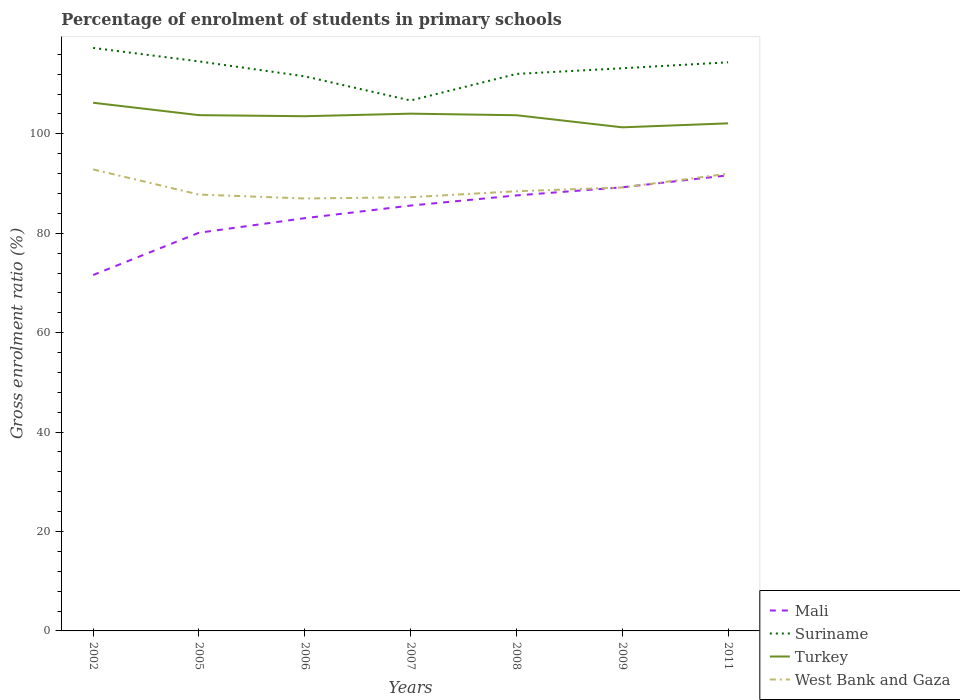How many different coloured lines are there?
Your answer should be very brief. 4. Does the line corresponding to Mali intersect with the line corresponding to Turkey?
Your answer should be very brief. No. Across all years, what is the maximum percentage of students enrolled in primary schools in Mali?
Keep it short and to the point. 71.61. What is the total percentage of students enrolled in primary schools in Turkey in the graph?
Provide a succinct answer. 1.44. What is the difference between the highest and the second highest percentage of students enrolled in primary schools in Turkey?
Provide a short and direct response. 4.95. What is the difference between the highest and the lowest percentage of students enrolled in primary schools in Suriname?
Provide a short and direct response. 4. Is the percentage of students enrolled in primary schools in West Bank and Gaza strictly greater than the percentage of students enrolled in primary schools in Suriname over the years?
Ensure brevity in your answer.  Yes. Are the values on the major ticks of Y-axis written in scientific E-notation?
Ensure brevity in your answer.  No. Does the graph contain any zero values?
Ensure brevity in your answer.  No. Where does the legend appear in the graph?
Your response must be concise. Bottom right. How many legend labels are there?
Ensure brevity in your answer.  4. What is the title of the graph?
Give a very brief answer. Percentage of enrolment of students in primary schools. What is the Gross enrolment ratio (%) in Mali in 2002?
Ensure brevity in your answer.  71.61. What is the Gross enrolment ratio (%) of Suriname in 2002?
Make the answer very short. 117.29. What is the Gross enrolment ratio (%) of Turkey in 2002?
Your response must be concise. 106.26. What is the Gross enrolment ratio (%) in West Bank and Gaza in 2002?
Offer a very short reply. 92.85. What is the Gross enrolment ratio (%) of Mali in 2005?
Ensure brevity in your answer.  80.11. What is the Gross enrolment ratio (%) of Suriname in 2005?
Offer a very short reply. 114.58. What is the Gross enrolment ratio (%) of Turkey in 2005?
Offer a very short reply. 103.77. What is the Gross enrolment ratio (%) of West Bank and Gaza in 2005?
Provide a short and direct response. 87.79. What is the Gross enrolment ratio (%) of Mali in 2006?
Give a very brief answer. 83.04. What is the Gross enrolment ratio (%) of Suriname in 2006?
Provide a short and direct response. 111.58. What is the Gross enrolment ratio (%) of Turkey in 2006?
Your answer should be compact. 103.55. What is the Gross enrolment ratio (%) in West Bank and Gaza in 2006?
Your answer should be compact. 87.01. What is the Gross enrolment ratio (%) of Mali in 2007?
Provide a succinct answer. 85.58. What is the Gross enrolment ratio (%) in Suriname in 2007?
Make the answer very short. 106.72. What is the Gross enrolment ratio (%) in Turkey in 2007?
Your response must be concise. 104.07. What is the Gross enrolment ratio (%) in West Bank and Gaza in 2007?
Your response must be concise. 87.26. What is the Gross enrolment ratio (%) in Mali in 2008?
Provide a succinct answer. 87.62. What is the Gross enrolment ratio (%) in Suriname in 2008?
Ensure brevity in your answer.  112.06. What is the Gross enrolment ratio (%) in Turkey in 2008?
Give a very brief answer. 103.75. What is the Gross enrolment ratio (%) of West Bank and Gaza in 2008?
Your response must be concise. 88.46. What is the Gross enrolment ratio (%) of Mali in 2009?
Offer a terse response. 89.25. What is the Gross enrolment ratio (%) of Suriname in 2009?
Keep it short and to the point. 113.2. What is the Gross enrolment ratio (%) of Turkey in 2009?
Your answer should be compact. 101.32. What is the Gross enrolment ratio (%) of West Bank and Gaza in 2009?
Give a very brief answer. 89.21. What is the Gross enrolment ratio (%) of Mali in 2011?
Ensure brevity in your answer.  91.66. What is the Gross enrolment ratio (%) in Suriname in 2011?
Your response must be concise. 114.4. What is the Gross enrolment ratio (%) of Turkey in 2011?
Ensure brevity in your answer.  102.12. What is the Gross enrolment ratio (%) of West Bank and Gaza in 2011?
Your answer should be very brief. 91.98. Across all years, what is the maximum Gross enrolment ratio (%) of Mali?
Your answer should be very brief. 91.66. Across all years, what is the maximum Gross enrolment ratio (%) of Suriname?
Provide a short and direct response. 117.29. Across all years, what is the maximum Gross enrolment ratio (%) of Turkey?
Your answer should be very brief. 106.26. Across all years, what is the maximum Gross enrolment ratio (%) in West Bank and Gaza?
Offer a terse response. 92.85. Across all years, what is the minimum Gross enrolment ratio (%) in Mali?
Provide a succinct answer. 71.61. Across all years, what is the minimum Gross enrolment ratio (%) of Suriname?
Offer a terse response. 106.72. Across all years, what is the minimum Gross enrolment ratio (%) in Turkey?
Provide a short and direct response. 101.32. Across all years, what is the minimum Gross enrolment ratio (%) in West Bank and Gaza?
Your response must be concise. 87.01. What is the total Gross enrolment ratio (%) of Mali in the graph?
Ensure brevity in your answer.  588.87. What is the total Gross enrolment ratio (%) of Suriname in the graph?
Provide a short and direct response. 789.83. What is the total Gross enrolment ratio (%) of Turkey in the graph?
Your response must be concise. 724.84. What is the total Gross enrolment ratio (%) of West Bank and Gaza in the graph?
Your answer should be very brief. 624.56. What is the difference between the Gross enrolment ratio (%) in Mali in 2002 and that in 2005?
Ensure brevity in your answer.  -8.5. What is the difference between the Gross enrolment ratio (%) of Suriname in 2002 and that in 2005?
Your answer should be very brief. 2.71. What is the difference between the Gross enrolment ratio (%) in Turkey in 2002 and that in 2005?
Provide a succinct answer. 2.5. What is the difference between the Gross enrolment ratio (%) of West Bank and Gaza in 2002 and that in 2005?
Offer a terse response. 5.06. What is the difference between the Gross enrolment ratio (%) of Mali in 2002 and that in 2006?
Make the answer very short. -11.44. What is the difference between the Gross enrolment ratio (%) of Suriname in 2002 and that in 2006?
Your answer should be compact. 5.71. What is the difference between the Gross enrolment ratio (%) in Turkey in 2002 and that in 2006?
Your answer should be very brief. 2.71. What is the difference between the Gross enrolment ratio (%) in West Bank and Gaza in 2002 and that in 2006?
Offer a very short reply. 5.84. What is the difference between the Gross enrolment ratio (%) of Mali in 2002 and that in 2007?
Your answer should be compact. -13.97. What is the difference between the Gross enrolment ratio (%) in Suriname in 2002 and that in 2007?
Offer a terse response. 10.58. What is the difference between the Gross enrolment ratio (%) in Turkey in 2002 and that in 2007?
Give a very brief answer. 2.2. What is the difference between the Gross enrolment ratio (%) of West Bank and Gaza in 2002 and that in 2007?
Offer a very short reply. 5.59. What is the difference between the Gross enrolment ratio (%) of Mali in 2002 and that in 2008?
Ensure brevity in your answer.  -16.01. What is the difference between the Gross enrolment ratio (%) of Suriname in 2002 and that in 2008?
Offer a terse response. 5.23. What is the difference between the Gross enrolment ratio (%) in Turkey in 2002 and that in 2008?
Ensure brevity in your answer.  2.51. What is the difference between the Gross enrolment ratio (%) in West Bank and Gaza in 2002 and that in 2008?
Give a very brief answer. 4.39. What is the difference between the Gross enrolment ratio (%) in Mali in 2002 and that in 2009?
Provide a succinct answer. -17.64. What is the difference between the Gross enrolment ratio (%) of Suriname in 2002 and that in 2009?
Your answer should be very brief. 4.09. What is the difference between the Gross enrolment ratio (%) of Turkey in 2002 and that in 2009?
Your response must be concise. 4.95. What is the difference between the Gross enrolment ratio (%) of West Bank and Gaza in 2002 and that in 2009?
Ensure brevity in your answer.  3.64. What is the difference between the Gross enrolment ratio (%) in Mali in 2002 and that in 2011?
Your response must be concise. -20.06. What is the difference between the Gross enrolment ratio (%) of Suriname in 2002 and that in 2011?
Your answer should be compact. 2.89. What is the difference between the Gross enrolment ratio (%) of Turkey in 2002 and that in 2011?
Give a very brief answer. 4.15. What is the difference between the Gross enrolment ratio (%) of West Bank and Gaza in 2002 and that in 2011?
Offer a terse response. 0.87. What is the difference between the Gross enrolment ratio (%) of Mali in 2005 and that in 2006?
Make the answer very short. -2.93. What is the difference between the Gross enrolment ratio (%) in Suriname in 2005 and that in 2006?
Make the answer very short. 3. What is the difference between the Gross enrolment ratio (%) of Turkey in 2005 and that in 2006?
Provide a short and direct response. 0.21. What is the difference between the Gross enrolment ratio (%) in West Bank and Gaza in 2005 and that in 2006?
Your answer should be very brief. 0.78. What is the difference between the Gross enrolment ratio (%) in Mali in 2005 and that in 2007?
Provide a short and direct response. -5.47. What is the difference between the Gross enrolment ratio (%) in Suriname in 2005 and that in 2007?
Provide a short and direct response. 7.87. What is the difference between the Gross enrolment ratio (%) in Turkey in 2005 and that in 2007?
Ensure brevity in your answer.  -0.3. What is the difference between the Gross enrolment ratio (%) in West Bank and Gaza in 2005 and that in 2007?
Provide a succinct answer. 0.53. What is the difference between the Gross enrolment ratio (%) in Mali in 2005 and that in 2008?
Provide a short and direct response. -7.51. What is the difference between the Gross enrolment ratio (%) of Suriname in 2005 and that in 2008?
Give a very brief answer. 2.52. What is the difference between the Gross enrolment ratio (%) of Turkey in 2005 and that in 2008?
Ensure brevity in your answer.  0.02. What is the difference between the Gross enrolment ratio (%) in West Bank and Gaza in 2005 and that in 2008?
Your answer should be compact. -0.67. What is the difference between the Gross enrolment ratio (%) in Mali in 2005 and that in 2009?
Provide a short and direct response. -9.14. What is the difference between the Gross enrolment ratio (%) in Suriname in 2005 and that in 2009?
Offer a very short reply. 1.39. What is the difference between the Gross enrolment ratio (%) of Turkey in 2005 and that in 2009?
Keep it short and to the point. 2.45. What is the difference between the Gross enrolment ratio (%) in West Bank and Gaza in 2005 and that in 2009?
Ensure brevity in your answer.  -1.42. What is the difference between the Gross enrolment ratio (%) of Mali in 2005 and that in 2011?
Your answer should be very brief. -11.55. What is the difference between the Gross enrolment ratio (%) of Suriname in 2005 and that in 2011?
Ensure brevity in your answer.  0.18. What is the difference between the Gross enrolment ratio (%) in Turkey in 2005 and that in 2011?
Offer a terse response. 1.65. What is the difference between the Gross enrolment ratio (%) of West Bank and Gaza in 2005 and that in 2011?
Your answer should be compact. -4.19. What is the difference between the Gross enrolment ratio (%) of Mali in 2006 and that in 2007?
Provide a succinct answer. -2.53. What is the difference between the Gross enrolment ratio (%) of Suriname in 2006 and that in 2007?
Ensure brevity in your answer.  4.86. What is the difference between the Gross enrolment ratio (%) of Turkey in 2006 and that in 2007?
Offer a terse response. -0.51. What is the difference between the Gross enrolment ratio (%) in West Bank and Gaza in 2006 and that in 2007?
Keep it short and to the point. -0.25. What is the difference between the Gross enrolment ratio (%) in Mali in 2006 and that in 2008?
Make the answer very short. -4.58. What is the difference between the Gross enrolment ratio (%) of Suriname in 2006 and that in 2008?
Keep it short and to the point. -0.48. What is the difference between the Gross enrolment ratio (%) in Turkey in 2006 and that in 2008?
Provide a succinct answer. -0.2. What is the difference between the Gross enrolment ratio (%) of West Bank and Gaza in 2006 and that in 2008?
Provide a short and direct response. -1.46. What is the difference between the Gross enrolment ratio (%) in Mali in 2006 and that in 2009?
Provide a short and direct response. -6.21. What is the difference between the Gross enrolment ratio (%) in Suriname in 2006 and that in 2009?
Ensure brevity in your answer.  -1.62. What is the difference between the Gross enrolment ratio (%) in Turkey in 2006 and that in 2009?
Make the answer very short. 2.24. What is the difference between the Gross enrolment ratio (%) of West Bank and Gaza in 2006 and that in 2009?
Your answer should be compact. -2.21. What is the difference between the Gross enrolment ratio (%) in Mali in 2006 and that in 2011?
Your answer should be very brief. -8.62. What is the difference between the Gross enrolment ratio (%) of Suriname in 2006 and that in 2011?
Keep it short and to the point. -2.82. What is the difference between the Gross enrolment ratio (%) of Turkey in 2006 and that in 2011?
Offer a very short reply. 1.44. What is the difference between the Gross enrolment ratio (%) of West Bank and Gaza in 2006 and that in 2011?
Keep it short and to the point. -4.97. What is the difference between the Gross enrolment ratio (%) in Mali in 2007 and that in 2008?
Provide a short and direct response. -2.04. What is the difference between the Gross enrolment ratio (%) of Suriname in 2007 and that in 2008?
Provide a succinct answer. -5.34. What is the difference between the Gross enrolment ratio (%) of Turkey in 2007 and that in 2008?
Provide a short and direct response. 0.32. What is the difference between the Gross enrolment ratio (%) of West Bank and Gaza in 2007 and that in 2008?
Keep it short and to the point. -1.21. What is the difference between the Gross enrolment ratio (%) in Mali in 2007 and that in 2009?
Make the answer very short. -3.67. What is the difference between the Gross enrolment ratio (%) in Suriname in 2007 and that in 2009?
Ensure brevity in your answer.  -6.48. What is the difference between the Gross enrolment ratio (%) of Turkey in 2007 and that in 2009?
Your answer should be compact. 2.75. What is the difference between the Gross enrolment ratio (%) in West Bank and Gaza in 2007 and that in 2009?
Offer a terse response. -1.96. What is the difference between the Gross enrolment ratio (%) in Mali in 2007 and that in 2011?
Your answer should be very brief. -6.09. What is the difference between the Gross enrolment ratio (%) of Suriname in 2007 and that in 2011?
Provide a succinct answer. -7.69. What is the difference between the Gross enrolment ratio (%) in Turkey in 2007 and that in 2011?
Offer a very short reply. 1.95. What is the difference between the Gross enrolment ratio (%) of West Bank and Gaza in 2007 and that in 2011?
Give a very brief answer. -4.72. What is the difference between the Gross enrolment ratio (%) of Mali in 2008 and that in 2009?
Ensure brevity in your answer.  -1.63. What is the difference between the Gross enrolment ratio (%) of Suriname in 2008 and that in 2009?
Your response must be concise. -1.14. What is the difference between the Gross enrolment ratio (%) of Turkey in 2008 and that in 2009?
Ensure brevity in your answer.  2.43. What is the difference between the Gross enrolment ratio (%) of West Bank and Gaza in 2008 and that in 2009?
Your answer should be very brief. -0.75. What is the difference between the Gross enrolment ratio (%) of Mali in 2008 and that in 2011?
Give a very brief answer. -4.04. What is the difference between the Gross enrolment ratio (%) in Suriname in 2008 and that in 2011?
Provide a succinct answer. -2.34. What is the difference between the Gross enrolment ratio (%) in Turkey in 2008 and that in 2011?
Your response must be concise. 1.64. What is the difference between the Gross enrolment ratio (%) of West Bank and Gaza in 2008 and that in 2011?
Keep it short and to the point. -3.52. What is the difference between the Gross enrolment ratio (%) of Mali in 2009 and that in 2011?
Your answer should be compact. -2.41. What is the difference between the Gross enrolment ratio (%) of Suriname in 2009 and that in 2011?
Make the answer very short. -1.2. What is the difference between the Gross enrolment ratio (%) of Turkey in 2009 and that in 2011?
Make the answer very short. -0.8. What is the difference between the Gross enrolment ratio (%) in West Bank and Gaza in 2009 and that in 2011?
Give a very brief answer. -2.77. What is the difference between the Gross enrolment ratio (%) of Mali in 2002 and the Gross enrolment ratio (%) of Suriname in 2005?
Your answer should be compact. -42.98. What is the difference between the Gross enrolment ratio (%) of Mali in 2002 and the Gross enrolment ratio (%) of Turkey in 2005?
Offer a very short reply. -32.16. What is the difference between the Gross enrolment ratio (%) in Mali in 2002 and the Gross enrolment ratio (%) in West Bank and Gaza in 2005?
Keep it short and to the point. -16.18. What is the difference between the Gross enrolment ratio (%) in Suriname in 2002 and the Gross enrolment ratio (%) in Turkey in 2005?
Provide a succinct answer. 13.52. What is the difference between the Gross enrolment ratio (%) of Suriname in 2002 and the Gross enrolment ratio (%) of West Bank and Gaza in 2005?
Give a very brief answer. 29.5. What is the difference between the Gross enrolment ratio (%) in Turkey in 2002 and the Gross enrolment ratio (%) in West Bank and Gaza in 2005?
Your response must be concise. 18.47. What is the difference between the Gross enrolment ratio (%) in Mali in 2002 and the Gross enrolment ratio (%) in Suriname in 2006?
Offer a very short reply. -39.97. What is the difference between the Gross enrolment ratio (%) in Mali in 2002 and the Gross enrolment ratio (%) in Turkey in 2006?
Ensure brevity in your answer.  -31.95. What is the difference between the Gross enrolment ratio (%) in Mali in 2002 and the Gross enrolment ratio (%) in West Bank and Gaza in 2006?
Ensure brevity in your answer.  -15.4. What is the difference between the Gross enrolment ratio (%) of Suriname in 2002 and the Gross enrolment ratio (%) of Turkey in 2006?
Offer a terse response. 13.74. What is the difference between the Gross enrolment ratio (%) in Suriname in 2002 and the Gross enrolment ratio (%) in West Bank and Gaza in 2006?
Your response must be concise. 30.29. What is the difference between the Gross enrolment ratio (%) in Turkey in 2002 and the Gross enrolment ratio (%) in West Bank and Gaza in 2006?
Provide a short and direct response. 19.26. What is the difference between the Gross enrolment ratio (%) of Mali in 2002 and the Gross enrolment ratio (%) of Suriname in 2007?
Keep it short and to the point. -35.11. What is the difference between the Gross enrolment ratio (%) of Mali in 2002 and the Gross enrolment ratio (%) of Turkey in 2007?
Offer a terse response. -32.46. What is the difference between the Gross enrolment ratio (%) in Mali in 2002 and the Gross enrolment ratio (%) in West Bank and Gaza in 2007?
Offer a very short reply. -15.65. What is the difference between the Gross enrolment ratio (%) of Suriname in 2002 and the Gross enrolment ratio (%) of Turkey in 2007?
Offer a very short reply. 13.22. What is the difference between the Gross enrolment ratio (%) in Suriname in 2002 and the Gross enrolment ratio (%) in West Bank and Gaza in 2007?
Your response must be concise. 30.04. What is the difference between the Gross enrolment ratio (%) in Turkey in 2002 and the Gross enrolment ratio (%) in West Bank and Gaza in 2007?
Offer a terse response. 19.01. What is the difference between the Gross enrolment ratio (%) in Mali in 2002 and the Gross enrolment ratio (%) in Suriname in 2008?
Give a very brief answer. -40.45. What is the difference between the Gross enrolment ratio (%) in Mali in 2002 and the Gross enrolment ratio (%) in Turkey in 2008?
Provide a succinct answer. -32.14. What is the difference between the Gross enrolment ratio (%) of Mali in 2002 and the Gross enrolment ratio (%) of West Bank and Gaza in 2008?
Offer a terse response. -16.85. What is the difference between the Gross enrolment ratio (%) of Suriname in 2002 and the Gross enrolment ratio (%) of Turkey in 2008?
Provide a short and direct response. 13.54. What is the difference between the Gross enrolment ratio (%) in Suriname in 2002 and the Gross enrolment ratio (%) in West Bank and Gaza in 2008?
Offer a terse response. 28.83. What is the difference between the Gross enrolment ratio (%) of Turkey in 2002 and the Gross enrolment ratio (%) of West Bank and Gaza in 2008?
Your answer should be very brief. 17.8. What is the difference between the Gross enrolment ratio (%) in Mali in 2002 and the Gross enrolment ratio (%) in Suriname in 2009?
Offer a very short reply. -41.59. What is the difference between the Gross enrolment ratio (%) in Mali in 2002 and the Gross enrolment ratio (%) in Turkey in 2009?
Your answer should be compact. -29.71. What is the difference between the Gross enrolment ratio (%) of Mali in 2002 and the Gross enrolment ratio (%) of West Bank and Gaza in 2009?
Your answer should be compact. -17.61. What is the difference between the Gross enrolment ratio (%) of Suriname in 2002 and the Gross enrolment ratio (%) of Turkey in 2009?
Make the answer very short. 15.97. What is the difference between the Gross enrolment ratio (%) of Suriname in 2002 and the Gross enrolment ratio (%) of West Bank and Gaza in 2009?
Your answer should be compact. 28.08. What is the difference between the Gross enrolment ratio (%) of Turkey in 2002 and the Gross enrolment ratio (%) of West Bank and Gaza in 2009?
Your answer should be compact. 17.05. What is the difference between the Gross enrolment ratio (%) in Mali in 2002 and the Gross enrolment ratio (%) in Suriname in 2011?
Offer a very short reply. -42.79. What is the difference between the Gross enrolment ratio (%) in Mali in 2002 and the Gross enrolment ratio (%) in Turkey in 2011?
Offer a terse response. -30.51. What is the difference between the Gross enrolment ratio (%) of Mali in 2002 and the Gross enrolment ratio (%) of West Bank and Gaza in 2011?
Your answer should be compact. -20.37. What is the difference between the Gross enrolment ratio (%) in Suriname in 2002 and the Gross enrolment ratio (%) in Turkey in 2011?
Offer a terse response. 15.18. What is the difference between the Gross enrolment ratio (%) of Suriname in 2002 and the Gross enrolment ratio (%) of West Bank and Gaza in 2011?
Ensure brevity in your answer.  25.31. What is the difference between the Gross enrolment ratio (%) in Turkey in 2002 and the Gross enrolment ratio (%) in West Bank and Gaza in 2011?
Your response must be concise. 14.29. What is the difference between the Gross enrolment ratio (%) of Mali in 2005 and the Gross enrolment ratio (%) of Suriname in 2006?
Your answer should be compact. -31.47. What is the difference between the Gross enrolment ratio (%) of Mali in 2005 and the Gross enrolment ratio (%) of Turkey in 2006?
Your answer should be very brief. -23.44. What is the difference between the Gross enrolment ratio (%) in Mali in 2005 and the Gross enrolment ratio (%) in West Bank and Gaza in 2006?
Your answer should be very brief. -6.89. What is the difference between the Gross enrolment ratio (%) in Suriname in 2005 and the Gross enrolment ratio (%) in Turkey in 2006?
Keep it short and to the point. 11.03. What is the difference between the Gross enrolment ratio (%) of Suriname in 2005 and the Gross enrolment ratio (%) of West Bank and Gaza in 2006?
Give a very brief answer. 27.58. What is the difference between the Gross enrolment ratio (%) of Turkey in 2005 and the Gross enrolment ratio (%) of West Bank and Gaza in 2006?
Provide a short and direct response. 16.76. What is the difference between the Gross enrolment ratio (%) of Mali in 2005 and the Gross enrolment ratio (%) of Suriname in 2007?
Offer a very short reply. -26.6. What is the difference between the Gross enrolment ratio (%) of Mali in 2005 and the Gross enrolment ratio (%) of Turkey in 2007?
Your answer should be compact. -23.96. What is the difference between the Gross enrolment ratio (%) in Mali in 2005 and the Gross enrolment ratio (%) in West Bank and Gaza in 2007?
Offer a very short reply. -7.14. What is the difference between the Gross enrolment ratio (%) of Suriname in 2005 and the Gross enrolment ratio (%) of Turkey in 2007?
Provide a short and direct response. 10.52. What is the difference between the Gross enrolment ratio (%) of Suriname in 2005 and the Gross enrolment ratio (%) of West Bank and Gaza in 2007?
Ensure brevity in your answer.  27.33. What is the difference between the Gross enrolment ratio (%) of Turkey in 2005 and the Gross enrolment ratio (%) of West Bank and Gaza in 2007?
Make the answer very short. 16.51. What is the difference between the Gross enrolment ratio (%) in Mali in 2005 and the Gross enrolment ratio (%) in Suriname in 2008?
Offer a terse response. -31.95. What is the difference between the Gross enrolment ratio (%) of Mali in 2005 and the Gross enrolment ratio (%) of Turkey in 2008?
Your answer should be compact. -23.64. What is the difference between the Gross enrolment ratio (%) in Mali in 2005 and the Gross enrolment ratio (%) in West Bank and Gaza in 2008?
Keep it short and to the point. -8.35. What is the difference between the Gross enrolment ratio (%) of Suriname in 2005 and the Gross enrolment ratio (%) of Turkey in 2008?
Your answer should be compact. 10.83. What is the difference between the Gross enrolment ratio (%) of Suriname in 2005 and the Gross enrolment ratio (%) of West Bank and Gaza in 2008?
Your response must be concise. 26.12. What is the difference between the Gross enrolment ratio (%) in Turkey in 2005 and the Gross enrolment ratio (%) in West Bank and Gaza in 2008?
Your response must be concise. 15.31. What is the difference between the Gross enrolment ratio (%) in Mali in 2005 and the Gross enrolment ratio (%) in Suriname in 2009?
Your answer should be very brief. -33.09. What is the difference between the Gross enrolment ratio (%) of Mali in 2005 and the Gross enrolment ratio (%) of Turkey in 2009?
Offer a terse response. -21.21. What is the difference between the Gross enrolment ratio (%) of Mali in 2005 and the Gross enrolment ratio (%) of West Bank and Gaza in 2009?
Offer a very short reply. -9.1. What is the difference between the Gross enrolment ratio (%) of Suriname in 2005 and the Gross enrolment ratio (%) of Turkey in 2009?
Ensure brevity in your answer.  13.26. What is the difference between the Gross enrolment ratio (%) in Suriname in 2005 and the Gross enrolment ratio (%) in West Bank and Gaza in 2009?
Provide a succinct answer. 25.37. What is the difference between the Gross enrolment ratio (%) in Turkey in 2005 and the Gross enrolment ratio (%) in West Bank and Gaza in 2009?
Provide a succinct answer. 14.55. What is the difference between the Gross enrolment ratio (%) of Mali in 2005 and the Gross enrolment ratio (%) of Suriname in 2011?
Provide a short and direct response. -34.29. What is the difference between the Gross enrolment ratio (%) of Mali in 2005 and the Gross enrolment ratio (%) of Turkey in 2011?
Give a very brief answer. -22. What is the difference between the Gross enrolment ratio (%) of Mali in 2005 and the Gross enrolment ratio (%) of West Bank and Gaza in 2011?
Your response must be concise. -11.87. What is the difference between the Gross enrolment ratio (%) in Suriname in 2005 and the Gross enrolment ratio (%) in Turkey in 2011?
Make the answer very short. 12.47. What is the difference between the Gross enrolment ratio (%) of Suriname in 2005 and the Gross enrolment ratio (%) of West Bank and Gaza in 2011?
Make the answer very short. 22.6. What is the difference between the Gross enrolment ratio (%) in Turkey in 2005 and the Gross enrolment ratio (%) in West Bank and Gaza in 2011?
Your response must be concise. 11.79. What is the difference between the Gross enrolment ratio (%) in Mali in 2006 and the Gross enrolment ratio (%) in Suriname in 2007?
Keep it short and to the point. -23.67. What is the difference between the Gross enrolment ratio (%) in Mali in 2006 and the Gross enrolment ratio (%) in Turkey in 2007?
Offer a very short reply. -21.02. What is the difference between the Gross enrolment ratio (%) in Mali in 2006 and the Gross enrolment ratio (%) in West Bank and Gaza in 2007?
Give a very brief answer. -4.21. What is the difference between the Gross enrolment ratio (%) of Suriname in 2006 and the Gross enrolment ratio (%) of Turkey in 2007?
Offer a terse response. 7.51. What is the difference between the Gross enrolment ratio (%) in Suriname in 2006 and the Gross enrolment ratio (%) in West Bank and Gaza in 2007?
Offer a terse response. 24.32. What is the difference between the Gross enrolment ratio (%) in Turkey in 2006 and the Gross enrolment ratio (%) in West Bank and Gaza in 2007?
Your answer should be compact. 16.3. What is the difference between the Gross enrolment ratio (%) in Mali in 2006 and the Gross enrolment ratio (%) in Suriname in 2008?
Your answer should be compact. -29.02. What is the difference between the Gross enrolment ratio (%) in Mali in 2006 and the Gross enrolment ratio (%) in Turkey in 2008?
Give a very brief answer. -20.71. What is the difference between the Gross enrolment ratio (%) in Mali in 2006 and the Gross enrolment ratio (%) in West Bank and Gaza in 2008?
Your answer should be compact. -5.42. What is the difference between the Gross enrolment ratio (%) in Suriname in 2006 and the Gross enrolment ratio (%) in Turkey in 2008?
Keep it short and to the point. 7.83. What is the difference between the Gross enrolment ratio (%) in Suriname in 2006 and the Gross enrolment ratio (%) in West Bank and Gaza in 2008?
Provide a short and direct response. 23.12. What is the difference between the Gross enrolment ratio (%) of Turkey in 2006 and the Gross enrolment ratio (%) of West Bank and Gaza in 2008?
Make the answer very short. 15.09. What is the difference between the Gross enrolment ratio (%) in Mali in 2006 and the Gross enrolment ratio (%) in Suriname in 2009?
Ensure brevity in your answer.  -30.16. What is the difference between the Gross enrolment ratio (%) in Mali in 2006 and the Gross enrolment ratio (%) in Turkey in 2009?
Your response must be concise. -18.28. What is the difference between the Gross enrolment ratio (%) in Mali in 2006 and the Gross enrolment ratio (%) in West Bank and Gaza in 2009?
Offer a terse response. -6.17. What is the difference between the Gross enrolment ratio (%) in Suriname in 2006 and the Gross enrolment ratio (%) in Turkey in 2009?
Your answer should be compact. 10.26. What is the difference between the Gross enrolment ratio (%) in Suriname in 2006 and the Gross enrolment ratio (%) in West Bank and Gaza in 2009?
Provide a succinct answer. 22.37. What is the difference between the Gross enrolment ratio (%) in Turkey in 2006 and the Gross enrolment ratio (%) in West Bank and Gaza in 2009?
Keep it short and to the point. 14.34. What is the difference between the Gross enrolment ratio (%) of Mali in 2006 and the Gross enrolment ratio (%) of Suriname in 2011?
Provide a succinct answer. -31.36. What is the difference between the Gross enrolment ratio (%) in Mali in 2006 and the Gross enrolment ratio (%) in Turkey in 2011?
Give a very brief answer. -19.07. What is the difference between the Gross enrolment ratio (%) of Mali in 2006 and the Gross enrolment ratio (%) of West Bank and Gaza in 2011?
Provide a short and direct response. -8.94. What is the difference between the Gross enrolment ratio (%) in Suriname in 2006 and the Gross enrolment ratio (%) in Turkey in 2011?
Provide a succinct answer. 9.46. What is the difference between the Gross enrolment ratio (%) in Suriname in 2006 and the Gross enrolment ratio (%) in West Bank and Gaza in 2011?
Your answer should be compact. 19.6. What is the difference between the Gross enrolment ratio (%) of Turkey in 2006 and the Gross enrolment ratio (%) of West Bank and Gaza in 2011?
Your answer should be very brief. 11.57. What is the difference between the Gross enrolment ratio (%) of Mali in 2007 and the Gross enrolment ratio (%) of Suriname in 2008?
Give a very brief answer. -26.48. What is the difference between the Gross enrolment ratio (%) in Mali in 2007 and the Gross enrolment ratio (%) in Turkey in 2008?
Give a very brief answer. -18.18. What is the difference between the Gross enrolment ratio (%) of Mali in 2007 and the Gross enrolment ratio (%) of West Bank and Gaza in 2008?
Provide a succinct answer. -2.89. What is the difference between the Gross enrolment ratio (%) in Suriname in 2007 and the Gross enrolment ratio (%) in Turkey in 2008?
Your response must be concise. 2.96. What is the difference between the Gross enrolment ratio (%) in Suriname in 2007 and the Gross enrolment ratio (%) in West Bank and Gaza in 2008?
Offer a very short reply. 18.25. What is the difference between the Gross enrolment ratio (%) of Turkey in 2007 and the Gross enrolment ratio (%) of West Bank and Gaza in 2008?
Your answer should be compact. 15.61. What is the difference between the Gross enrolment ratio (%) of Mali in 2007 and the Gross enrolment ratio (%) of Suriname in 2009?
Provide a succinct answer. -27.62. What is the difference between the Gross enrolment ratio (%) in Mali in 2007 and the Gross enrolment ratio (%) in Turkey in 2009?
Give a very brief answer. -15.74. What is the difference between the Gross enrolment ratio (%) of Mali in 2007 and the Gross enrolment ratio (%) of West Bank and Gaza in 2009?
Offer a very short reply. -3.64. What is the difference between the Gross enrolment ratio (%) of Suriname in 2007 and the Gross enrolment ratio (%) of Turkey in 2009?
Your answer should be very brief. 5.4. What is the difference between the Gross enrolment ratio (%) in Suriname in 2007 and the Gross enrolment ratio (%) in West Bank and Gaza in 2009?
Your response must be concise. 17.5. What is the difference between the Gross enrolment ratio (%) of Turkey in 2007 and the Gross enrolment ratio (%) of West Bank and Gaza in 2009?
Make the answer very short. 14.85. What is the difference between the Gross enrolment ratio (%) in Mali in 2007 and the Gross enrolment ratio (%) in Suriname in 2011?
Offer a terse response. -28.83. What is the difference between the Gross enrolment ratio (%) in Mali in 2007 and the Gross enrolment ratio (%) in Turkey in 2011?
Your answer should be compact. -16.54. What is the difference between the Gross enrolment ratio (%) of Mali in 2007 and the Gross enrolment ratio (%) of West Bank and Gaza in 2011?
Offer a terse response. -6.4. What is the difference between the Gross enrolment ratio (%) in Suriname in 2007 and the Gross enrolment ratio (%) in Turkey in 2011?
Your answer should be compact. 4.6. What is the difference between the Gross enrolment ratio (%) of Suriname in 2007 and the Gross enrolment ratio (%) of West Bank and Gaza in 2011?
Make the answer very short. 14.74. What is the difference between the Gross enrolment ratio (%) in Turkey in 2007 and the Gross enrolment ratio (%) in West Bank and Gaza in 2011?
Ensure brevity in your answer.  12.09. What is the difference between the Gross enrolment ratio (%) of Mali in 2008 and the Gross enrolment ratio (%) of Suriname in 2009?
Ensure brevity in your answer.  -25.58. What is the difference between the Gross enrolment ratio (%) of Mali in 2008 and the Gross enrolment ratio (%) of Turkey in 2009?
Your answer should be compact. -13.7. What is the difference between the Gross enrolment ratio (%) of Mali in 2008 and the Gross enrolment ratio (%) of West Bank and Gaza in 2009?
Make the answer very short. -1.6. What is the difference between the Gross enrolment ratio (%) of Suriname in 2008 and the Gross enrolment ratio (%) of Turkey in 2009?
Offer a very short reply. 10.74. What is the difference between the Gross enrolment ratio (%) in Suriname in 2008 and the Gross enrolment ratio (%) in West Bank and Gaza in 2009?
Make the answer very short. 22.85. What is the difference between the Gross enrolment ratio (%) of Turkey in 2008 and the Gross enrolment ratio (%) of West Bank and Gaza in 2009?
Offer a very short reply. 14.54. What is the difference between the Gross enrolment ratio (%) in Mali in 2008 and the Gross enrolment ratio (%) in Suriname in 2011?
Give a very brief answer. -26.78. What is the difference between the Gross enrolment ratio (%) of Mali in 2008 and the Gross enrolment ratio (%) of Turkey in 2011?
Ensure brevity in your answer.  -14.5. What is the difference between the Gross enrolment ratio (%) of Mali in 2008 and the Gross enrolment ratio (%) of West Bank and Gaza in 2011?
Your answer should be very brief. -4.36. What is the difference between the Gross enrolment ratio (%) in Suriname in 2008 and the Gross enrolment ratio (%) in Turkey in 2011?
Make the answer very short. 9.94. What is the difference between the Gross enrolment ratio (%) in Suriname in 2008 and the Gross enrolment ratio (%) in West Bank and Gaza in 2011?
Your response must be concise. 20.08. What is the difference between the Gross enrolment ratio (%) of Turkey in 2008 and the Gross enrolment ratio (%) of West Bank and Gaza in 2011?
Keep it short and to the point. 11.77. What is the difference between the Gross enrolment ratio (%) in Mali in 2009 and the Gross enrolment ratio (%) in Suriname in 2011?
Offer a very short reply. -25.15. What is the difference between the Gross enrolment ratio (%) in Mali in 2009 and the Gross enrolment ratio (%) in Turkey in 2011?
Your answer should be compact. -12.87. What is the difference between the Gross enrolment ratio (%) of Mali in 2009 and the Gross enrolment ratio (%) of West Bank and Gaza in 2011?
Provide a short and direct response. -2.73. What is the difference between the Gross enrolment ratio (%) in Suriname in 2009 and the Gross enrolment ratio (%) in Turkey in 2011?
Provide a succinct answer. 11.08. What is the difference between the Gross enrolment ratio (%) in Suriname in 2009 and the Gross enrolment ratio (%) in West Bank and Gaza in 2011?
Offer a terse response. 21.22. What is the difference between the Gross enrolment ratio (%) of Turkey in 2009 and the Gross enrolment ratio (%) of West Bank and Gaza in 2011?
Offer a very short reply. 9.34. What is the average Gross enrolment ratio (%) of Mali per year?
Keep it short and to the point. 84.12. What is the average Gross enrolment ratio (%) in Suriname per year?
Your response must be concise. 112.83. What is the average Gross enrolment ratio (%) in Turkey per year?
Give a very brief answer. 103.55. What is the average Gross enrolment ratio (%) in West Bank and Gaza per year?
Your response must be concise. 89.22. In the year 2002, what is the difference between the Gross enrolment ratio (%) in Mali and Gross enrolment ratio (%) in Suriname?
Give a very brief answer. -45.68. In the year 2002, what is the difference between the Gross enrolment ratio (%) in Mali and Gross enrolment ratio (%) in Turkey?
Your response must be concise. -34.66. In the year 2002, what is the difference between the Gross enrolment ratio (%) of Mali and Gross enrolment ratio (%) of West Bank and Gaza?
Provide a short and direct response. -21.24. In the year 2002, what is the difference between the Gross enrolment ratio (%) of Suriname and Gross enrolment ratio (%) of Turkey?
Provide a succinct answer. 11.03. In the year 2002, what is the difference between the Gross enrolment ratio (%) in Suriname and Gross enrolment ratio (%) in West Bank and Gaza?
Your answer should be very brief. 24.44. In the year 2002, what is the difference between the Gross enrolment ratio (%) of Turkey and Gross enrolment ratio (%) of West Bank and Gaza?
Make the answer very short. 13.41. In the year 2005, what is the difference between the Gross enrolment ratio (%) in Mali and Gross enrolment ratio (%) in Suriname?
Provide a short and direct response. -34.47. In the year 2005, what is the difference between the Gross enrolment ratio (%) in Mali and Gross enrolment ratio (%) in Turkey?
Offer a terse response. -23.66. In the year 2005, what is the difference between the Gross enrolment ratio (%) in Mali and Gross enrolment ratio (%) in West Bank and Gaza?
Offer a terse response. -7.68. In the year 2005, what is the difference between the Gross enrolment ratio (%) of Suriname and Gross enrolment ratio (%) of Turkey?
Provide a succinct answer. 10.82. In the year 2005, what is the difference between the Gross enrolment ratio (%) in Suriname and Gross enrolment ratio (%) in West Bank and Gaza?
Your response must be concise. 26.79. In the year 2005, what is the difference between the Gross enrolment ratio (%) in Turkey and Gross enrolment ratio (%) in West Bank and Gaza?
Provide a short and direct response. 15.98. In the year 2006, what is the difference between the Gross enrolment ratio (%) of Mali and Gross enrolment ratio (%) of Suriname?
Provide a succinct answer. -28.54. In the year 2006, what is the difference between the Gross enrolment ratio (%) in Mali and Gross enrolment ratio (%) in Turkey?
Ensure brevity in your answer.  -20.51. In the year 2006, what is the difference between the Gross enrolment ratio (%) in Mali and Gross enrolment ratio (%) in West Bank and Gaza?
Give a very brief answer. -3.96. In the year 2006, what is the difference between the Gross enrolment ratio (%) of Suriname and Gross enrolment ratio (%) of Turkey?
Make the answer very short. 8.03. In the year 2006, what is the difference between the Gross enrolment ratio (%) of Suriname and Gross enrolment ratio (%) of West Bank and Gaza?
Your answer should be compact. 24.57. In the year 2006, what is the difference between the Gross enrolment ratio (%) in Turkey and Gross enrolment ratio (%) in West Bank and Gaza?
Your response must be concise. 16.55. In the year 2007, what is the difference between the Gross enrolment ratio (%) in Mali and Gross enrolment ratio (%) in Suriname?
Offer a very short reply. -21.14. In the year 2007, what is the difference between the Gross enrolment ratio (%) in Mali and Gross enrolment ratio (%) in Turkey?
Offer a very short reply. -18.49. In the year 2007, what is the difference between the Gross enrolment ratio (%) of Mali and Gross enrolment ratio (%) of West Bank and Gaza?
Give a very brief answer. -1.68. In the year 2007, what is the difference between the Gross enrolment ratio (%) of Suriname and Gross enrolment ratio (%) of Turkey?
Your answer should be very brief. 2.65. In the year 2007, what is the difference between the Gross enrolment ratio (%) in Suriname and Gross enrolment ratio (%) in West Bank and Gaza?
Offer a very short reply. 19.46. In the year 2007, what is the difference between the Gross enrolment ratio (%) in Turkey and Gross enrolment ratio (%) in West Bank and Gaza?
Your answer should be very brief. 16.81. In the year 2008, what is the difference between the Gross enrolment ratio (%) in Mali and Gross enrolment ratio (%) in Suriname?
Your response must be concise. -24.44. In the year 2008, what is the difference between the Gross enrolment ratio (%) of Mali and Gross enrolment ratio (%) of Turkey?
Offer a terse response. -16.13. In the year 2008, what is the difference between the Gross enrolment ratio (%) in Mali and Gross enrolment ratio (%) in West Bank and Gaza?
Keep it short and to the point. -0.84. In the year 2008, what is the difference between the Gross enrolment ratio (%) of Suriname and Gross enrolment ratio (%) of Turkey?
Ensure brevity in your answer.  8.31. In the year 2008, what is the difference between the Gross enrolment ratio (%) in Suriname and Gross enrolment ratio (%) in West Bank and Gaza?
Offer a very short reply. 23.6. In the year 2008, what is the difference between the Gross enrolment ratio (%) in Turkey and Gross enrolment ratio (%) in West Bank and Gaza?
Your response must be concise. 15.29. In the year 2009, what is the difference between the Gross enrolment ratio (%) in Mali and Gross enrolment ratio (%) in Suriname?
Keep it short and to the point. -23.95. In the year 2009, what is the difference between the Gross enrolment ratio (%) of Mali and Gross enrolment ratio (%) of Turkey?
Give a very brief answer. -12.07. In the year 2009, what is the difference between the Gross enrolment ratio (%) in Mali and Gross enrolment ratio (%) in West Bank and Gaza?
Make the answer very short. 0.04. In the year 2009, what is the difference between the Gross enrolment ratio (%) of Suriname and Gross enrolment ratio (%) of Turkey?
Keep it short and to the point. 11.88. In the year 2009, what is the difference between the Gross enrolment ratio (%) in Suriname and Gross enrolment ratio (%) in West Bank and Gaza?
Offer a terse response. 23.98. In the year 2009, what is the difference between the Gross enrolment ratio (%) of Turkey and Gross enrolment ratio (%) of West Bank and Gaza?
Your answer should be very brief. 12.1. In the year 2011, what is the difference between the Gross enrolment ratio (%) of Mali and Gross enrolment ratio (%) of Suriname?
Keep it short and to the point. -22.74. In the year 2011, what is the difference between the Gross enrolment ratio (%) of Mali and Gross enrolment ratio (%) of Turkey?
Keep it short and to the point. -10.45. In the year 2011, what is the difference between the Gross enrolment ratio (%) in Mali and Gross enrolment ratio (%) in West Bank and Gaza?
Offer a terse response. -0.32. In the year 2011, what is the difference between the Gross enrolment ratio (%) in Suriname and Gross enrolment ratio (%) in Turkey?
Keep it short and to the point. 12.29. In the year 2011, what is the difference between the Gross enrolment ratio (%) of Suriname and Gross enrolment ratio (%) of West Bank and Gaza?
Provide a succinct answer. 22.42. In the year 2011, what is the difference between the Gross enrolment ratio (%) in Turkey and Gross enrolment ratio (%) in West Bank and Gaza?
Your answer should be very brief. 10.14. What is the ratio of the Gross enrolment ratio (%) of Mali in 2002 to that in 2005?
Your response must be concise. 0.89. What is the ratio of the Gross enrolment ratio (%) of Suriname in 2002 to that in 2005?
Ensure brevity in your answer.  1.02. What is the ratio of the Gross enrolment ratio (%) of Turkey in 2002 to that in 2005?
Provide a succinct answer. 1.02. What is the ratio of the Gross enrolment ratio (%) of West Bank and Gaza in 2002 to that in 2005?
Your answer should be compact. 1.06. What is the ratio of the Gross enrolment ratio (%) of Mali in 2002 to that in 2006?
Offer a terse response. 0.86. What is the ratio of the Gross enrolment ratio (%) of Suriname in 2002 to that in 2006?
Your response must be concise. 1.05. What is the ratio of the Gross enrolment ratio (%) in Turkey in 2002 to that in 2006?
Your answer should be very brief. 1.03. What is the ratio of the Gross enrolment ratio (%) in West Bank and Gaza in 2002 to that in 2006?
Your answer should be very brief. 1.07. What is the ratio of the Gross enrolment ratio (%) in Mali in 2002 to that in 2007?
Ensure brevity in your answer.  0.84. What is the ratio of the Gross enrolment ratio (%) of Suriname in 2002 to that in 2007?
Offer a very short reply. 1.1. What is the ratio of the Gross enrolment ratio (%) of Turkey in 2002 to that in 2007?
Keep it short and to the point. 1.02. What is the ratio of the Gross enrolment ratio (%) in West Bank and Gaza in 2002 to that in 2007?
Your response must be concise. 1.06. What is the ratio of the Gross enrolment ratio (%) of Mali in 2002 to that in 2008?
Provide a succinct answer. 0.82. What is the ratio of the Gross enrolment ratio (%) in Suriname in 2002 to that in 2008?
Ensure brevity in your answer.  1.05. What is the ratio of the Gross enrolment ratio (%) in Turkey in 2002 to that in 2008?
Give a very brief answer. 1.02. What is the ratio of the Gross enrolment ratio (%) of West Bank and Gaza in 2002 to that in 2008?
Make the answer very short. 1.05. What is the ratio of the Gross enrolment ratio (%) of Mali in 2002 to that in 2009?
Keep it short and to the point. 0.8. What is the ratio of the Gross enrolment ratio (%) of Suriname in 2002 to that in 2009?
Keep it short and to the point. 1.04. What is the ratio of the Gross enrolment ratio (%) in Turkey in 2002 to that in 2009?
Provide a short and direct response. 1.05. What is the ratio of the Gross enrolment ratio (%) of West Bank and Gaza in 2002 to that in 2009?
Provide a succinct answer. 1.04. What is the ratio of the Gross enrolment ratio (%) of Mali in 2002 to that in 2011?
Your answer should be very brief. 0.78. What is the ratio of the Gross enrolment ratio (%) of Suriname in 2002 to that in 2011?
Provide a short and direct response. 1.03. What is the ratio of the Gross enrolment ratio (%) of Turkey in 2002 to that in 2011?
Your answer should be compact. 1.04. What is the ratio of the Gross enrolment ratio (%) in West Bank and Gaza in 2002 to that in 2011?
Give a very brief answer. 1.01. What is the ratio of the Gross enrolment ratio (%) of Mali in 2005 to that in 2006?
Give a very brief answer. 0.96. What is the ratio of the Gross enrolment ratio (%) of Suriname in 2005 to that in 2006?
Offer a very short reply. 1.03. What is the ratio of the Gross enrolment ratio (%) in West Bank and Gaza in 2005 to that in 2006?
Keep it short and to the point. 1.01. What is the ratio of the Gross enrolment ratio (%) in Mali in 2005 to that in 2007?
Keep it short and to the point. 0.94. What is the ratio of the Gross enrolment ratio (%) in Suriname in 2005 to that in 2007?
Keep it short and to the point. 1.07. What is the ratio of the Gross enrolment ratio (%) of Turkey in 2005 to that in 2007?
Give a very brief answer. 1. What is the ratio of the Gross enrolment ratio (%) of Mali in 2005 to that in 2008?
Your answer should be very brief. 0.91. What is the ratio of the Gross enrolment ratio (%) in Suriname in 2005 to that in 2008?
Offer a very short reply. 1.02. What is the ratio of the Gross enrolment ratio (%) of West Bank and Gaza in 2005 to that in 2008?
Offer a terse response. 0.99. What is the ratio of the Gross enrolment ratio (%) in Mali in 2005 to that in 2009?
Keep it short and to the point. 0.9. What is the ratio of the Gross enrolment ratio (%) of Suriname in 2005 to that in 2009?
Offer a very short reply. 1.01. What is the ratio of the Gross enrolment ratio (%) of Turkey in 2005 to that in 2009?
Your answer should be very brief. 1.02. What is the ratio of the Gross enrolment ratio (%) of Mali in 2005 to that in 2011?
Your answer should be compact. 0.87. What is the ratio of the Gross enrolment ratio (%) of Turkey in 2005 to that in 2011?
Your response must be concise. 1.02. What is the ratio of the Gross enrolment ratio (%) of West Bank and Gaza in 2005 to that in 2011?
Your answer should be very brief. 0.95. What is the ratio of the Gross enrolment ratio (%) in Mali in 2006 to that in 2007?
Your answer should be compact. 0.97. What is the ratio of the Gross enrolment ratio (%) in Suriname in 2006 to that in 2007?
Your answer should be compact. 1.05. What is the ratio of the Gross enrolment ratio (%) of Mali in 2006 to that in 2008?
Ensure brevity in your answer.  0.95. What is the ratio of the Gross enrolment ratio (%) in West Bank and Gaza in 2006 to that in 2008?
Offer a terse response. 0.98. What is the ratio of the Gross enrolment ratio (%) in Mali in 2006 to that in 2009?
Ensure brevity in your answer.  0.93. What is the ratio of the Gross enrolment ratio (%) of Suriname in 2006 to that in 2009?
Keep it short and to the point. 0.99. What is the ratio of the Gross enrolment ratio (%) in Turkey in 2006 to that in 2009?
Make the answer very short. 1.02. What is the ratio of the Gross enrolment ratio (%) of West Bank and Gaza in 2006 to that in 2009?
Your answer should be very brief. 0.98. What is the ratio of the Gross enrolment ratio (%) in Mali in 2006 to that in 2011?
Make the answer very short. 0.91. What is the ratio of the Gross enrolment ratio (%) in Suriname in 2006 to that in 2011?
Keep it short and to the point. 0.98. What is the ratio of the Gross enrolment ratio (%) in Turkey in 2006 to that in 2011?
Give a very brief answer. 1.01. What is the ratio of the Gross enrolment ratio (%) in West Bank and Gaza in 2006 to that in 2011?
Keep it short and to the point. 0.95. What is the ratio of the Gross enrolment ratio (%) of Mali in 2007 to that in 2008?
Offer a terse response. 0.98. What is the ratio of the Gross enrolment ratio (%) of Suriname in 2007 to that in 2008?
Provide a succinct answer. 0.95. What is the ratio of the Gross enrolment ratio (%) in Turkey in 2007 to that in 2008?
Provide a succinct answer. 1. What is the ratio of the Gross enrolment ratio (%) of West Bank and Gaza in 2007 to that in 2008?
Ensure brevity in your answer.  0.99. What is the ratio of the Gross enrolment ratio (%) in Mali in 2007 to that in 2009?
Make the answer very short. 0.96. What is the ratio of the Gross enrolment ratio (%) of Suriname in 2007 to that in 2009?
Your response must be concise. 0.94. What is the ratio of the Gross enrolment ratio (%) of Turkey in 2007 to that in 2009?
Provide a succinct answer. 1.03. What is the ratio of the Gross enrolment ratio (%) in West Bank and Gaza in 2007 to that in 2009?
Provide a succinct answer. 0.98. What is the ratio of the Gross enrolment ratio (%) of Mali in 2007 to that in 2011?
Your answer should be very brief. 0.93. What is the ratio of the Gross enrolment ratio (%) of Suriname in 2007 to that in 2011?
Ensure brevity in your answer.  0.93. What is the ratio of the Gross enrolment ratio (%) in Turkey in 2007 to that in 2011?
Make the answer very short. 1.02. What is the ratio of the Gross enrolment ratio (%) of West Bank and Gaza in 2007 to that in 2011?
Provide a succinct answer. 0.95. What is the ratio of the Gross enrolment ratio (%) in Mali in 2008 to that in 2009?
Your answer should be compact. 0.98. What is the ratio of the Gross enrolment ratio (%) in Suriname in 2008 to that in 2009?
Offer a very short reply. 0.99. What is the ratio of the Gross enrolment ratio (%) of Turkey in 2008 to that in 2009?
Offer a terse response. 1.02. What is the ratio of the Gross enrolment ratio (%) of West Bank and Gaza in 2008 to that in 2009?
Give a very brief answer. 0.99. What is the ratio of the Gross enrolment ratio (%) in Mali in 2008 to that in 2011?
Offer a very short reply. 0.96. What is the ratio of the Gross enrolment ratio (%) of Suriname in 2008 to that in 2011?
Offer a very short reply. 0.98. What is the ratio of the Gross enrolment ratio (%) of West Bank and Gaza in 2008 to that in 2011?
Your answer should be compact. 0.96. What is the ratio of the Gross enrolment ratio (%) of Mali in 2009 to that in 2011?
Ensure brevity in your answer.  0.97. What is the ratio of the Gross enrolment ratio (%) of West Bank and Gaza in 2009 to that in 2011?
Your answer should be very brief. 0.97. What is the difference between the highest and the second highest Gross enrolment ratio (%) in Mali?
Make the answer very short. 2.41. What is the difference between the highest and the second highest Gross enrolment ratio (%) in Suriname?
Offer a very short reply. 2.71. What is the difference between the highest and the second highest Gross enrolment ratio (%) of Turkey?
Ensure brevity in your answer.  2.2. What is the difference between the highest and the second highest Gross enrolment ratio (%) of West Bank and Gaza?
Your answer should be compact. 0.87. What is the difference between the highest and the lowest Gross enrolment ratio (%) in Mali?
Make the answer very short. 20.06. What is the difference between the highest and the lowest Gross enrolment ratio (%) in Suriname?
Your response must be concise. 10.58. What is the difference between the highest and the lowest Gross enrolment ratio (%) of Turkey?
Your answer should be compact. 4.95. What is the difference between the highest and the lowest Gross enrolment ratio (%) in West Bank and Gaza?
Ensure brevity in your answer.  5.84. 